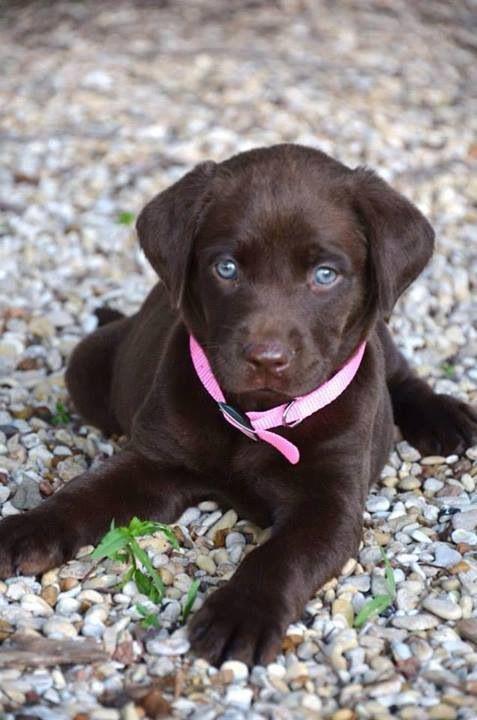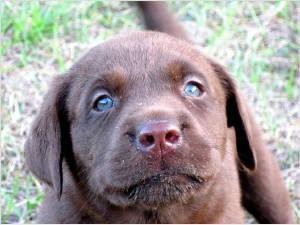The first image is the image on the left, the second image is the image on the right. Analyze the images presented: Is the assertion "No grassy ground is visible in one of the dog images." valid? Answer yes or no. Yes. 